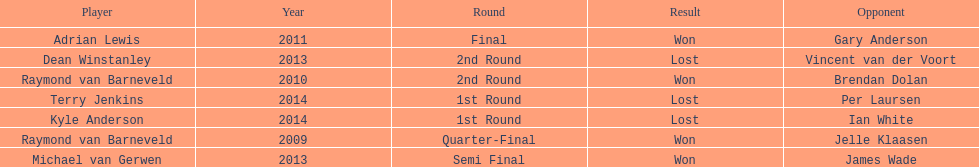Is dean winstanley listed above or below kyle anderson? Above. 